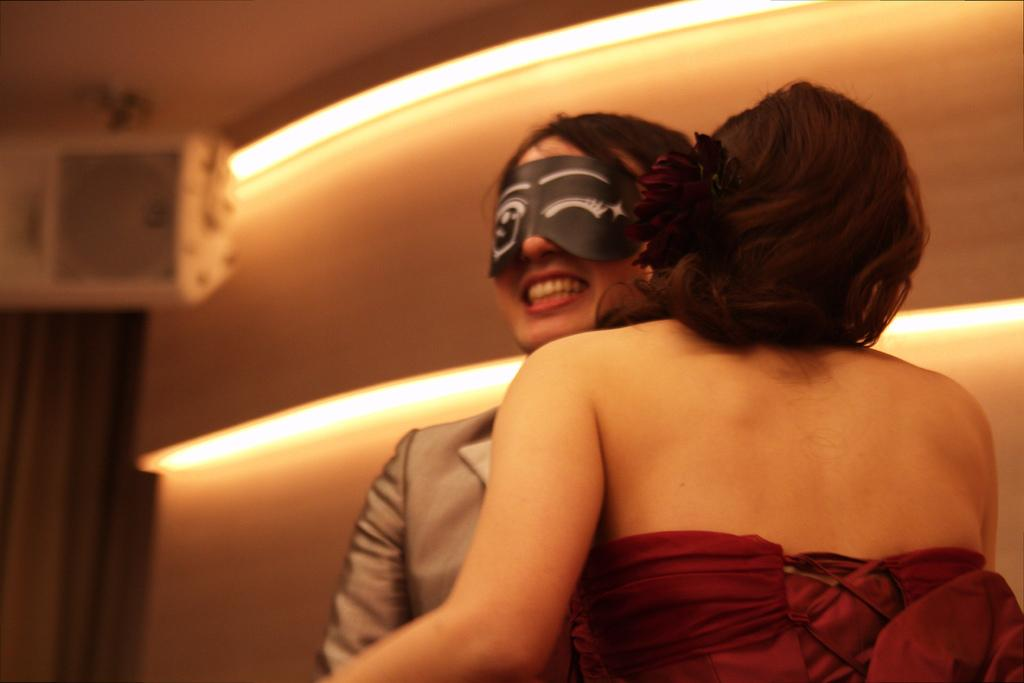How many people are in the image? There are two persons in the image. What is the person on the left side of the image wearing? One person is wearing an eye cover. How does the person with the eye cover appear to feel? The person with the eye cover is smiling. What can be seen in the background of the image? There are lights and a wall in the background of the image. How does the zebra compare to the person wearing the eye cover in the image? There is no zebra present in the image, so it cannot be compared to the person wearing the eye cover. 